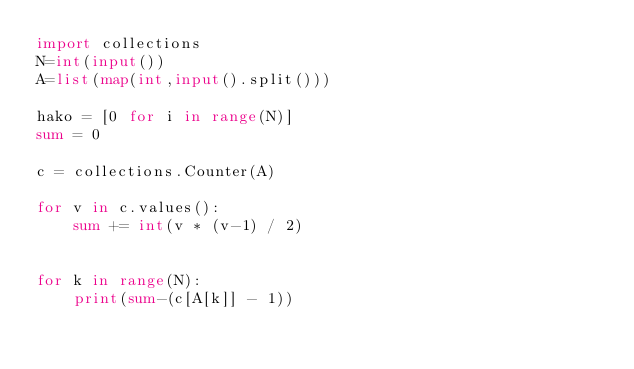Convert code to text. <code><loc_0><loc_0><loc_500><loc_500><_Python_>import collections
N=int(input())
A=list(map(int,input().split()))

hako = [0 for i in range(N)]
sum = 0

c = collections.Counter(A)

for v in c.values():
    sum += int(v * (v-1) / 2)


for k in range(N):
    print(sum-(c[A[k]] - 1))</code> 